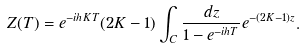Convert formula to latex. <formula><loc_0><loc_0><loc_500><loc_500>Z ( T ) = e ^ { - i h K T } ( 2 K - 1 ) \int _ { C } \frac { d z } { 1 - e ^ { - i h T } } e ^ { - ( 2 K - 1 ) z } .</formula> 